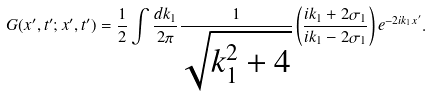Convert formula to latex. <formula><loc_0><loc_0><loc_500><loc_500>G ( x ^ { \prime } , t ^ { \prime } ; x ^ { \prime } , t ^ { \prime } ) = \frac { 1 } { 2 } \int \frac { d k _ { 1 } } { 2 \pi } \frac { 1 } { \sqrt { k _ { 1 } ^ { 2 } + 4 } } \left ( \frac { i k _ { 1 } + 2 \sigma _ { 1 } } { i k _ { 1 } - 2 \sigma _ { 1 } } \right ) e ^ { - 2 i k _ { 1 } x ^ { \prime } } .</formula> 